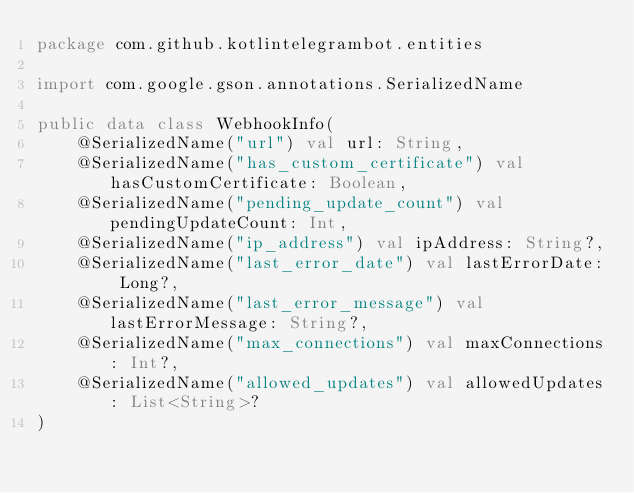<code> <loc_0><loc_0><loc_500><loc_500><_Kotlin_>package com.github.kotlintelegrambot.entities

import com.google.gson.annotations.SerializedName

public data class WebhookInfo(
    @SerializedName("url") val url: String,
    @SerializedName("has_custom_certificate") val hasCustomCertificate: Boolean,
    @SerializedName("pending_update_count") val pendingUpdateCount: Int,
    @SerializedName("ip_address") val ipAddress: String?,
    @SerializedName("last_error_date") val lastErrorDate: Long?,
    @SerializedName("last_error_message") val lastErrorMessage: String?,
    @SerializedName("max_connections") val maxConnections: Int?,
    @SerializedName("allowed_updates") val allowedUpdates: List<String>?
)
</code> 